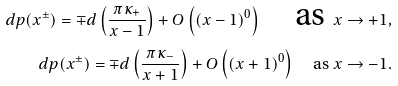Convert formula to latex. <formula><loc_0><loc_0><loc_500><loc_500>d p ( x ^ { \pm } ) = \mp d \left ( \frac { \pi \kappa _ { + } } { x - 1 } \right ) + O \left ( ( x - 1 ) ^ { 0 } \right ) \quad \text {as } x \rightarrow + 1 , \\ d p ( x ^ { \pm } ) = \mp d \left ( \frac { \pi \kappa _ { - } } { x + 1 } \right ) + O \left ( ( x + 1 ) ^ { 0 } \right ) \quad \text {as } x \rightarrow - 1 .</formula> 